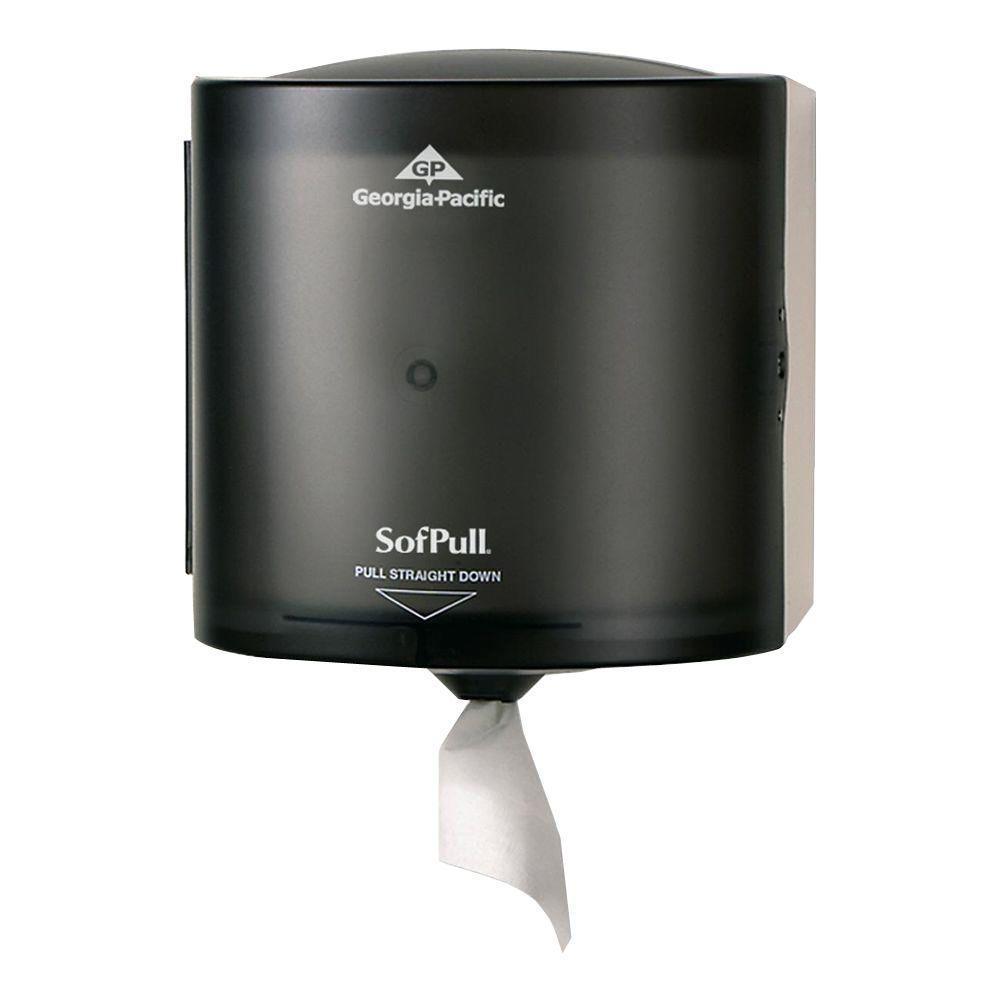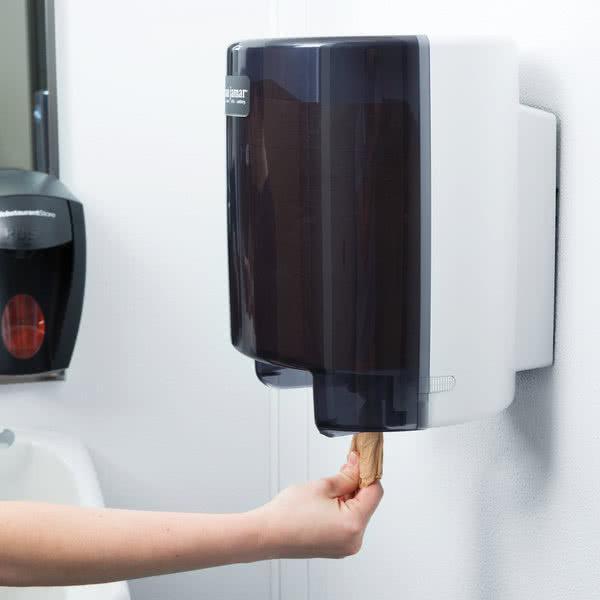The first image is the image on the left, the second image is the image on the right. Considering the images on both sides, is "In one of the image there are two paper rolls next to a paper towel dispenser." valid? Answer yes or no. No. The first image is the image on the left, the second image is the image on the right. Evaluate the accuracy of this statement regarding the images: "The image on the right shows a person reaching for a disposable paper towel.". Is it true? Answer yes or no. Yes. 